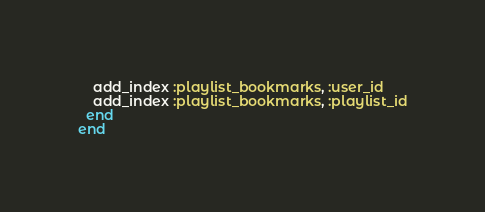<code> <loc_0><loc_0><loc_500><loc_500><_Ruby_>
    add_index :playlist_bookmarks, :user_id
    add_index :playlist_bookmarks, :playlist_id
  end
end
</code> 